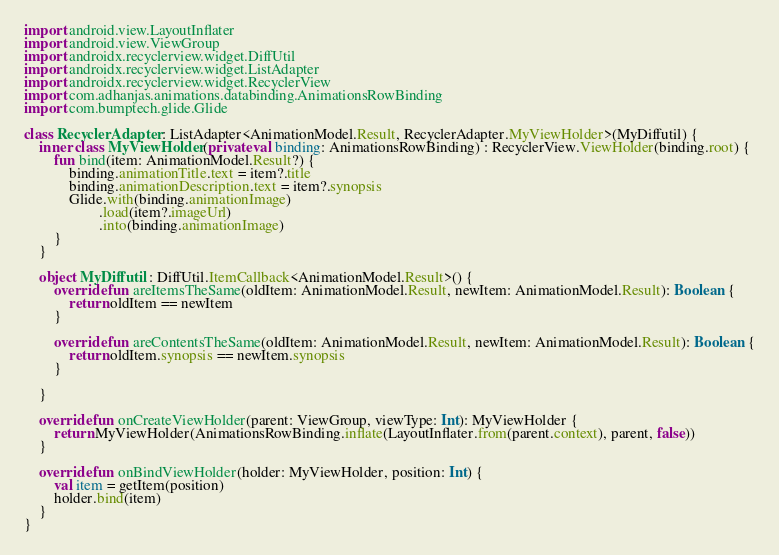Convert code to text. <code><loc_0><loc_0><loc_500><loc_500><_Kotlin_>
import android.view.LayoutInflater
import android.view.ViewGroup
import androidx.recyclerview.widget.DiffUtil
import androidx.recyclerview.widget.ListAdapter
import androidx.recyclerview.widget.RecyclerView
import com.adhanjas.animations.databinding.AnimationsRowBinding
import com.bumptech.glide.Glide

class RecyclerAdapter : ListAdapter<AnimationModel.Result, RecyclerAdapter.MyViewHolder>(MyDiffutil) {
    inner class MyViewHolder(private val binding: AnimationsRowBinding) : RecyclerView.ViewHolder(binding.root) {
        fun bind(item: AnimationModel.Result?) {
            binding.animationTitle.text = item?.title
            binding.animationDescription.text = item?.synopsis
            Glide.with(binding.animationImage)
                    .load(item?.imageUrl)
                    .into(binding.animationImage)
        }
    }

    object MyDiffutil : DiffUtil.ItemCallback<AnimationModel.Result>() {
        override fun areItemsTheSame(oldItem: AnimationModel.Result, newItem: AnimationModel.Result): Boolean {
            return oldItem == newItem
        }

        override fun areContentsTheSame(oldItem: AnimationModel.Result, newItem: AnimationModel.Result): Boolean {
            return oldItem.synopsis == newItem.synopsis
        }

    }

    override fun onCreateViewHolder(parent: ViewGroup, viewType: Int): MyViewHolder {
        return MyViewHolder(AnimationsRowBinding.inflate(LayoutInflater.from(parent.context), parent, false))
    }

    override fun onBindViewHolder(holder: MyViewHolder, position: Int) {
        val item = getItem(position)
        holder.bind(item)
    }
}</code> 